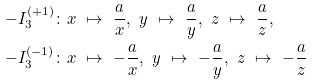Convert formula to latex. <formula><loc_0><loc_0><loc_500><loc_500>- I _ { 3 } ^ { ( + 1 ) } & \colon x \ \mapsto \ \frac { a } { x } , \ y \ \mapsto \ \frac { a } { y } , \ z \ \mapsto \ \frac { a } { z } , \\ - I _ { 3 } ^ { ( - 1 ) } & \colon x \ \mapsto \ - \frac { a } { x } , \ y \ \mapsto \ - \frac { a } { y } , \ z \ \mapsto \ - \frac { a } { z }</formula> 